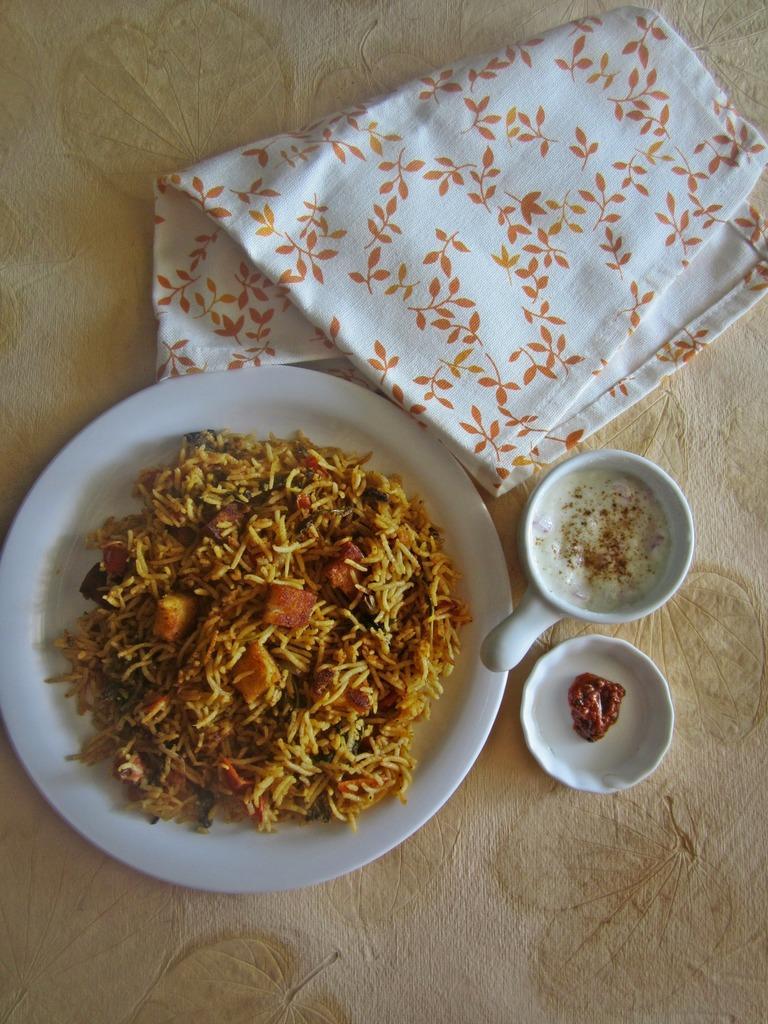Please provide a concise description of this image. In the image there is rice in a plate with a pickle beside it on a small plate and a coffee cup along with a napkin on a table. 